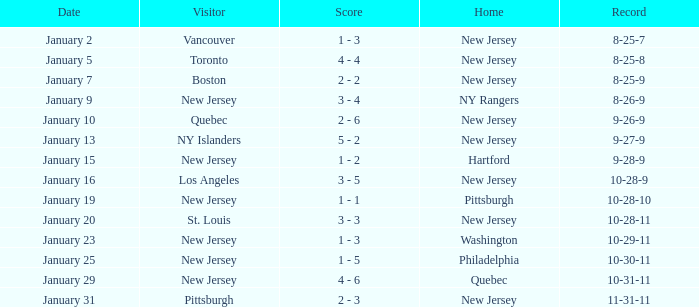What was the home team when the visiting team was Toronto? New Jersey. 